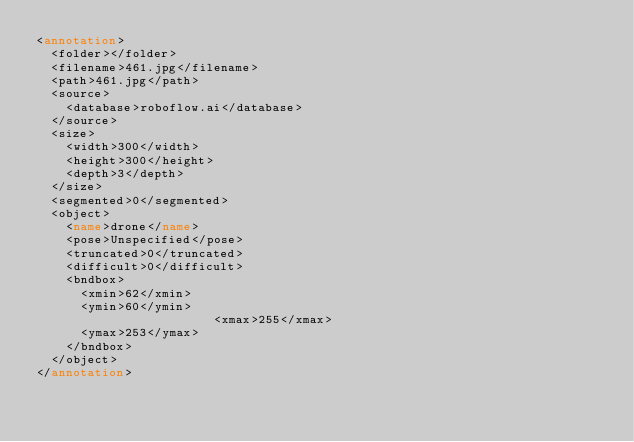<code> <loc_0><loc_0><loc_500><loc_500><_XML_><annotation>
	<folder></folder>
	<filename>461.jpg</filename>
	<path>461.jpg</path>
	<source>
		<database>roboflow.ai</database>
	</source>
	<size>
		<width>300</width>
		<height>300</height>
		<depth>3</depth>
	</size>
	<segmented>0</segmented>
	<object>
		<name>drone</name>
		<pose>Unspecified</pose>
		<truncated>0</truncated>
		<difficult>0</difficult>
		<bndbox>
			<xmin>62</xmin>
			<ymin>60</ymin>
                        <xmax>255</xmax>
			<ymax>253</ymax>
		</bndbox>
	</object>
</annotation>
</code> 